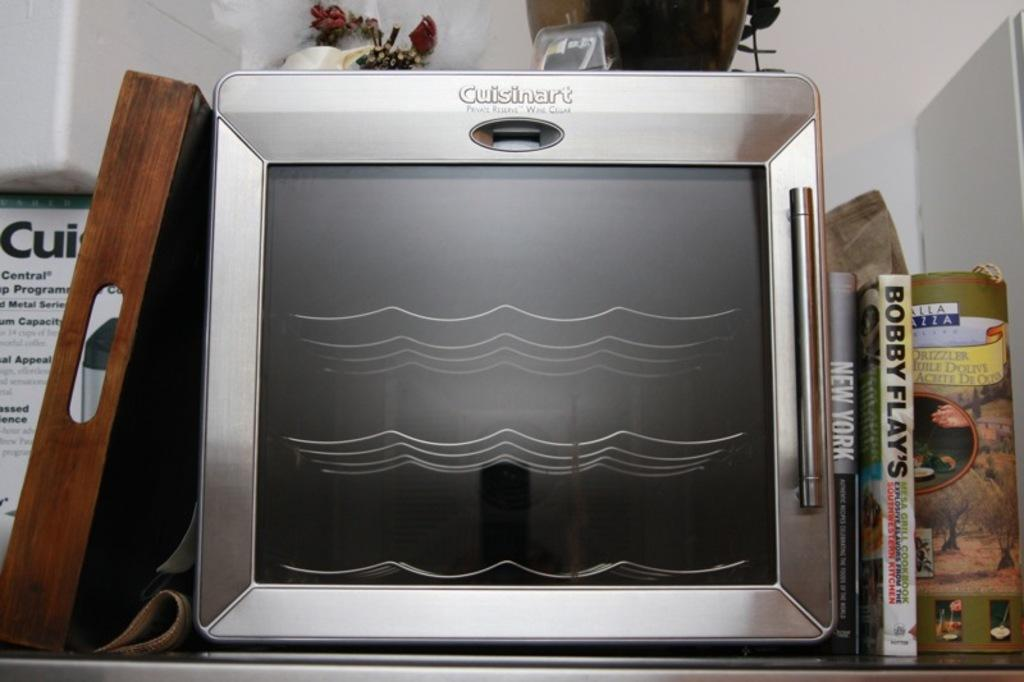What type of appliance is visible in the image? There is a microwave oven in the image. What else can be seen in the image besides the microwave oven? There are books and a serving plate in the image. What grade does the calculator receive in the image? There is no calculator present in the image, so it cannot receive a grade. 